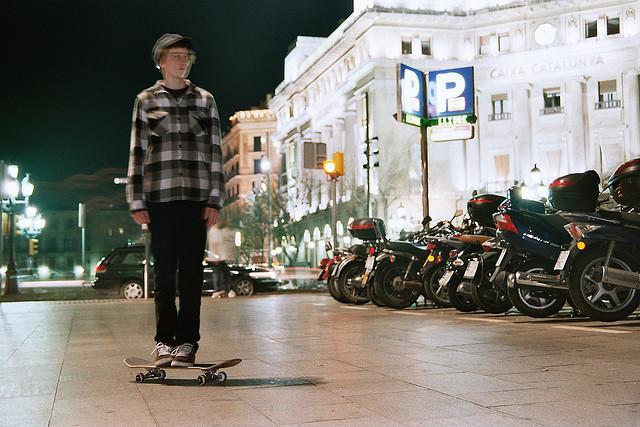What is the boy standing on?
Be succinct. Skateboard. What color is the car behind the boy?
Write a very short answer. Black. What design is the boy's shirt?
Short answer required. Plaid. 